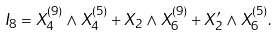<formula> <loc_0><loc_0><loc_500><loc_500>I _ { 8 } = X _ { 4 } ^ { ( 9 ) } \wedge X _ { 4 } ^ { ( 5 ) } + X _ { 2 } \wedge X _ { 6 } ^ { ( 9 ) } + X ^ { \prime } _ { 2 } \wedge X _ { 6 } ^ { ( 5 ) } .</formula> 